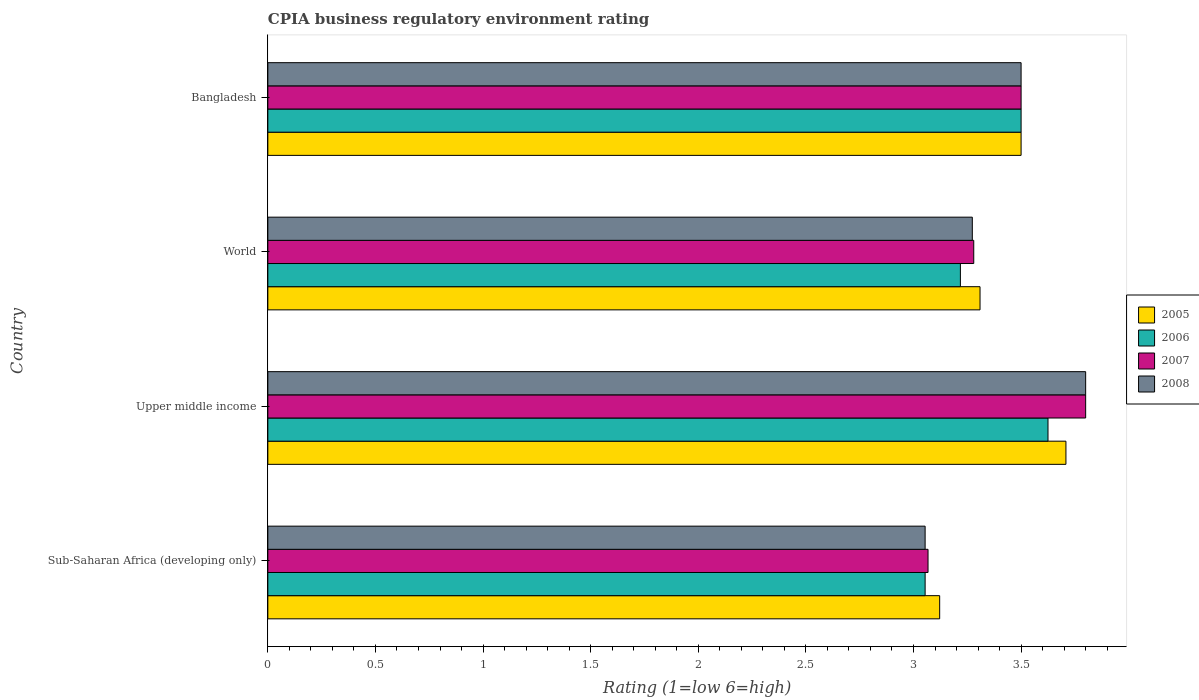How many different coloured bars are there?
Your answer should be very brief. 4. How many groups of bars are there?
Ensure brevity in your answer.  4. Are the number of bars per tick equal to the number of legend labels?
Offer a very short reply. Yes. Are the number of bars on each tick of the Y-axis equal?
Your answer should be very brief. Yes. How many bars are there on the 3rd tick from the top?
Provide a succinct answer. 4. What is the label of the 4th group of bars from the top?
Give a very brief answer. Sub-Saharan Africa (developing only). In how many cases, is the number of bars for a given country not equal to the number of legend labels?
Give a very brief answer. 0. What is the CPIA rating in 2007 in World?
Your response must be concise. 3.28. Across all countries, what is the maximum CPIA rating in 2005?
Offer a very short reply. 3.71. Across all countries, what is the minimum CPIA rating in 2005?
Provide a succinct answer. 3.12. In which country was the CPIA rating in 2008 maximum?
Your answer should be very brief. Upper middle income. In which country was the CPIA rating in 2007 minimum?
Offer a terse response. Sub-Saharan Africa (developing only). What is the total CPIA rating in 2007 in the graph?
Offer a very short reply. 13.65. What is the difference between the CPIA rating in 2008 in Bangladesh and that in Upper middle income?
Your answer should be very brief. -0.3. What is the difference between the CPIA rating in 2008 in Bangladesh and the CPIA rating in 2006 in Sub-Saharan Africa (developing only)?
Provide a succinct answer. 0.45. What is the average CPIA rating in 2006 per country?
Give a very brief answer. 3.35. What is the difference between the CPIA rating in 2005 and CPIA rating in 2006 in Sub-Saharan Africa (developing only)?
Make the answer very short. 0.07. What is the ratio of the CPIA rating in 2008 in Sub-Saharan Africa (developing only) to that in World?
Make the answer very short. 0.93. Is the difference between the CPIA rating in 2005 in Bangladesh and Sub-Saharan Africa (developing only) greater than the difference between the CPIA rating in 2006 in Bangladesh and Sub-Saharan Africa (developing only)?
Offer a terse response. No. What is the difference between the highest and the second highest CPIA rating in 2007?
Offer a very short reply. 0.3. What is the difference between the highest and the lowest CPIA rating in 2008?
Provide a succinct answer. 0.75. Is the sum of the CPIA rating in 2006 in Bangladesh and Upper middle income greater than the maximum CPIA rating in 2008 across all countries?
Ensure brevity in your answer.  Yes. Is it the case that in every country, the sum of the CPIA rating in 2005 and CPIA rating in 2007 is greater than the sum of CPIA rating in 2008 and CPIA rating in 2006?
Provide a succinct answer. No. What does the 2nd bar from the top in Sub-Saharan Africa (developing only) represents?
Your answer should be very brief. 2007. Is it the case that in every country, the sum of the CPIA rating in 2006 and CPIA rating in 2007 is greater than the CPIA rating in 2005?
Provide a short and direct response. Yes. What is the difference between two consecutive major ticks on the X-axis?
Your answer should be very brief. 0.5. Does the graph contain any zero values?
Offer a terse response. No. Does the graph contain grids?
Ensure brevity in your answer.  No. Where does the legend appear in the graph?
Your answer should be compact. Center right. How are the legend labels stacked?
Offer a terse response. Vertical. What is the title of the graph?
Ensure brevity in your answer.  CPIA business regulatory environment rating. Does "2015" appear as one of the legend labels in the graph?
Offer a very short reply. No. What is the label or title of the X-axis?
Offer a very short reply. Rating (1=low 6=high). What is the Rating (1=low 6=high) of 2005 in Sub-Saharan Africa (developing only)?
Make the answer very short. 3.12. What is the Rating (1=low 6=high) of 2006 in Sub-Saharan Africa (developing only)?
Your response must be concise. 3.05. What is the Rating (1=low 6=high) in 2007 in Sub-Saharan Africa (developing only)?
Make the answer very short. 3.07. What is the Rating (1=low 6=high) in 2008 in Sub-Saharan Africa (developing only)?
Offer a terse response. 3.05. What is the Rating (1=low 6=high) of 2005 in Upper middle income?
Your response must be concise. 3.71. What is the Rating (1=low 6=high) in 2006 in Upper middle income?
Offer a very short reply. 3.62. What is the Rating (1=low 6=high) in 2005 in World?
Your answer should be compact. 3.31. What is the Rating (1=low 6=high) of 2006 in World?
Offer a very short reply. 3.22. What is the Rating (1=low 6=high) of 2007 in World?
Offer a terse response. 3.28. What is the Rating (1=low 6=high) in 2008 in World?
Your answer should be very brief. 3.27. What is the Rating (1=low 6=high) of 2005 in Bangladesh?
Offer a very short reply. 3.5. What is the Rating (1=low 6=high) of 2008 in Bangladesh?
Provide a succinct answer. 3.5. Across all countries, what is the maximum Rating (1=low 6=high) in 2005?
Your answer should be compact. 3.71. Across all countries, what is the maximum Rating (1=low 6=high) in 2006?
Ensure brevity in your answer.  3.62. Across all countries, what is the minimum Rating (1=low 6=high) in 2005?
Make the answer very short. 3.12. Across all countries, what is the minimum Rating (1=low 6=high) in 2006?
Your response must be concise. 3.05. Across all countries, what is the minimum Rating (1=low 6=high) in 2007?
Provide a short and direct response. 3.07. Across all countries, what is the minimum Rating (1=low 6=high) of 2008?
Ensure brevity in your answer.  3.05. What is the total Rating (1=low 6=high) in 2005 in the graph?
Make the answer very short. 13.64. What is the total Rating (1=low 6=high) of 2006 in the graph?
Make the answer very short. 13.4. What is the total Rating (1=low 6=high) in 2007 in the graph?
Keep it short and to the point. 13.65. What is the total Rating (1=low 6=high) of 2008 in the graph?
Offer a very short reply. 13.63. What is the difference between the Rating (1=low 6=high) in 2005 in Sub-Saharan Africa (developing only) and that in Upper middle income?
Your response must be concise. -0.59. What is the difference between the Rating (1=low 6=high) in 2006 in Sub-Saharan Africa (developing only) and that in Upper middle income?
Ensure brevity in your answer.  -0.57. What is the difference between the Rating (1=low 6=high) of 2007 in Sub-Saharan Africa (developing only) and that in Upper middle income?
Ensure brevity in your answer.  -0.73. What is the difference between the Rating (1=low 6=high) in 2008 in Sub-Saharan Africa (developing only) and that in Upper middle income?
Provide a succinct answer. -0.75. What is the difference between the Rating (1=low 6=high) in 2005 in Sub-Saharan Africa (developing only) and that in World?
Provide a short and direct response. -0.19. What is the difference between the Rating (1=low 6=high) of 2006 in Sub-Saharan Africa (developing only) and that in World?
Provide a short and direct response. -0.16. What is the difference between the Rating (1=low 6=high) of 2007 in Sub-Saharan Africa (developing only) and that in World?
Your answer should be very brief. -0.21. What is the difference between the Rating (1=low 6=high) in 2008 in Sub-Saharan Africa (developing only) and that in World?
Ensure brevity in your answer.  -0.22. What is the difference between the Rating (1=low 6=high) in 2005 in Sub-Saharan Africa (developing only) and that in Bangladesh?
Provide a succinct answer. -0.38. What is the difference between the Rating (1=low 6=high) of 2006 in Sub-Saharan Africa (developing only) and that in Bangladesh?
Keep it short and to the point. -0.45. What is the difference between the Rating (1=low 6=high) of 2007 in Sub-Saharan Africa (developing only) and that in Bangladesh?
Provide a short and direct response. -0.43. What is the difference between the Rating (1=low 6=high) of 2008 in Sub-Saharan Africa (developing only) and that in Bangladesh?
Make the answer very short. -0.45. What is the difference between the Rating (1=low 6=high) in 2005 in Upper middle income and that in World?
Keep it short and to the point. 0.4. What is the difference between the Rating (1=low 6=high) in 2006 in Upper middle income and that in World?
Offer a very short reply. 0.41. What is the difference between the Rating (1=low 6=high) in 2007 in Upper middle income and that in World?
Provide a succinct answer. 0.52. What is the difference between the Rating (1=low 6=high) of 2008 in Upper middle income and that in World?
Give a very brief answer. 0.53. What is the difference between the Rating (1=low 6=high) in 2005 in Upper middle income and that in Bangladesh?
Your response must be concise. 0.21. What is the difference between the Rating (1=low 6=high) of 2006 in Upper middle income and that in Bangladesh?
Your answer should be compact. 0.12. What is the difference between the Rating (1=low 6=high) in 2005 in World and that in Bangladesh?
Offer a very short reply. -0.19. What is the difference between the Rating (1=low 6=high) of 2006 in World and that in Bangladesh?
Give a very brief answer. -0.28. What is the difference between the Rating (1=low 6=high) in 2007 in World and that in Bangladesh?
Provide a short and direct response. -0.22. What is the difference between the Rating (1=low 6=high) in 2008 in World and that in Bangladesh?
Offer a terse response. -0.23. What is the difference between the Rating (1=low 6=high) in 2005 in Sub-Saharan Africa (developing only) and the Rating (1=low 6=high) in 2006 in Upper middle income?
Ensure brevity in your answer.  -0.5. What is the difference between the Rating (1=low 6=high) of 2005 in Sub-Saharan Africa (developing only) and the Rating (1=low 6=high) of 2007 in Upper middle income?
Offer a very short reply. -0.68. What is the difference between the Rating (1=low 6=high) of 2005 in Sub-Saharan Africa (developing only) and the Rating (1=low 6=high) of 2008 in Upper middle income?
Provide a succinct answer. -0.68. What is the difference between the Rating (1=low 6=high) of 2006 in Sub-Saharan Africa (developing only) and the Rating (1=low 6=high) of 2007 in Upper middle income?
Provide a short and direct response. -0.75. What is the difference between the Rating (1=low 6=high) in 2006 in Sub-Saharan Africa (developing only) and the Rating (1=low 6=high) in 2008 in Upper middle income?
Your response must be concise. -0.75. What is the difference between the Rating (1=low 6=high) of 2007 in Sub-Saharan Africa (developing only) and the Rating (1=low 6=high) of 2008 in Upper middle income?
Offer a terse response. -0.73. What is the difference between the Rating (1=low 6=high) in 2005 in Sub-Saharan Africa (developing only) and the Rating (1=low 6=high) in 2006 in World?
Offer a very short reply. -0.1. What is the difference between the Rating (1=low 6=high) in 2005 in Sub-Saharan Africa (developing only) and the Rating (1=low 6=high) in 2007 in World?
Provide a succinct answer. -0.16. What is the difference between the Rating (1=low 6=high) in 2005 in Sub-Saharan Africa (developing only) and the Rating (1=low 6=high) in 2008 in World?
Your answer should be very brief. -0.15. What is the difference between the Rating (1=low 6=high) of 2006 in Sub-Saharan Africa (developing only) and the Rating (1=low 6=high) of 2007 in World?
Offer a terse response. -0.23. What is the difference between the Rating (1=low 6=high) of 2006 in Sub-Saharan Africa (developing only) and the Rating (1=low 6=high) of 2008 in World?
Offer a very short reply. -0.22. What is the difference between the Rating (1=low 6=high) of 2007 in Sub-Saharan Africa (developing only) and the Rating (1=low 6=high) of 2008 in World?
Your answer should be very brief. -0.21. What is the difference between the Rating (1=low 6=high) in 2005 in Sub-Saharan Africa (developing only) and the Rating (1=low 6=high) in 2006 in Bangladesh?
Provide a short and direct response. -0.38. What is the difference between the Rating (1=low 6=high) in 2005 in Sub-Saharan Africa (developing only) and the Rating (1=low 6=high) in 2007 in Bangladesh?
Provide a short and direct response. -0.38. What is the difference between the Rating (1=low 6=high) in 2005 in Sub-Saharan Africa (developing only) and the Rating (1=low 6=high) in 2008 in Bangladesh?
Your answer should be compact. -0.38. What is the difference between the Rating (1=low 6=high) of 2006 in Sub-Saharan Africa (developing only) and the Rating (1=low 6=high) of 2007 in Bangladesh?
Offer a terse response. -0.45. What is the difference between the Rating (1=low 6=high) in 2006 in Sub-Saharan Africa (developing only) and the Rating (1=low 6=high) in 2008 in Bangladesh?
Give a very brief answer. -0.45. What is the difference between the Rating (1=low 6=high) of 2007 in Sub-Saharan Africa (developing only) and the Rating (1=low 6=high) of 2008 in Bangladesh?
Provide a succinct answer. -0.43. What is the difference between the Rating (1=low 6=high) of 2005 in Upper middle income and the Rating (1=low 6=high) of 2006 in World?
Make the answer very short. 0.49. What is the difference between the Rating (1=low 6=high) in 2005 in Upper middle income and the Rating (1=low 6=high) in 2007 in World?
Give a very brief answer. 0.43. What is the difference between the Rating (1=low 6=high) in 2005 in Upper middle income and the Rating (1=low 6=high) in 2008 in World?
Your answer should be compact. 0.43. What is the difference between the Rating (1=low 6=high) in 2006 in Upper middle income and the Rating (1=low 6=high) in 2007 in World?
Keep it short and to the point. 0.34. What is the difference between the Rating (1=low 6=high) in 2006 in Upper middle income and the Rating (1=low 6=high) in 2008 in World?
Provide a short and direct response. 0.35. What is the difference between the Rating (1=low 6=high) of 2007 in Upper middle income and the Rating (1=low 6=high) of 2008 in World?
Give a very brief answer. 0.53. What is the difference between the Rating (1=low 6=high) in 2005 in Upper middle income and the Rating (1=low 6=high) in 2006 in Bangladesh?
Provide a succinct answer. 0.21. What is the difference between the Rating (1=low 6=high) in 2005 in Upper middle income and the Rating (1=low 6=high) in 2007 in Bangladesh?
Offer a very short reply. 0.21. What is the difference between the Rating (1=low 6=high) in 2005 in Upper middle income and the Rating (1=low 6=high) in 2008 in Bangladesh?
Your answer should be compact. 0.21. What is the difference between the Rating (1=low 6=high) in 2006 in Upper middle income and the Rating (1=low 6=high) in 2007 in Bangladesh?
Your answer should be very brief. 0.12. What is the difference between the Rating (1=low 6=high) in 2007 in Upper middle income and the Rating (1=low 6=high) in 2008 in Bangladesh?
Offer a terse response. 0.3. What is the difference between the Rating (1=low 6=high) in 2005 in World and the Rating (1=low 6=high) in 2006 in Bangladesh?
Make the answer very short. -0.19. What is the difference between the Rating (1=low 6=high) of 2005 in World and the Rating (1=low 6=high) of 2007 in Bangladesh?
Provide a succinct answer. -0.19. What is the difference between the Rating (1=low 6=high) of 2005 in World and the Rating (1=low 6=high) of 2008 in Bangladesh?
Provide a succinct answer. -0.19. What is the difference between the Rating (1=low 6=high) of 2006 in World and the Rating (1=low 6=high) of 2007 in Bangladesh?
Your answer should be very brief. -0.28. What is the difference between the Rating (1=low 6=high) in 2006 in World and the Rating (1=low 6=high) in 2008 in Bangladesh?
Ensure brevity in your answer.  -0.28. What is the difference between the Rating (1=low 6=high) of 2007 in World and the Rating (1=low 6=high) of 2008 in Bangladesh?
Offer a very short reply. -0.22. What is the average Rating (1=low 6=high) of 2005 per country?
Your answer should be very brief. 3.41. What is the average Rating (1=low 6=high) of 2006 per country?
Offer a terse response. 3.35. What is the average Rating (1=low 6=high) in 2007 per country?
Your answer should be very brief. 3.41. What is the average Rating (1=low 6=high) in 2008 per country?
Your answer should be compact. 3.41. What is the difference between the Rating (1=low 6=high) in 2005 and Rating (1=low 6=high) in 2006 in Sub-Saharan Africa (developing only)?
Offer a very short reply. 0.07. What is the difference between the Rating (1=low 6=high) of 2005 and Rating (1=low 6=high) of 2007 in Sub-Saharan Africa (developing only)?
Ensure brevity in your answer.  0.05. What is the difference between the Rating (1=low 6=high) in 2005 and Rating (1=low 6=high) in 2008 in Sub-Saharan Africa (developing only)?
Offer a terse response. 0.07. What is the difference between the Rating (1=low 6=high) in 2006 and Rating (1=low 6=high) in 2007 in Sub-Saharan Africa (developing only)?
Make the answer very short. -0.01. What is the difference between the Rating (1=low 6=high) in 2006 and Rating (1=low 6=high) in 2008 in Sub-Saharan Africa (developing only)?
Your response must be concise. 0. What is the difference between the Rating (1=low 6=high) of 2007 and Rating (1=low 6=high) of 2008 in Sub-Saharan Africa (developing only)?
Offer a terse response. 0.01. What is the difference between the Rating (1=low 6=high) of 2005 and Rating (1=low 6=high) of 2006 in Upper middle income?
Your answer should be compact. 0.08. What is the difference between the Rating (1=low 6=high) of 2005 and Rating (1=low 6=high) of 2007 in Upper middle income?
Give a very brief answer. -0.09. What is the difference between the Rating (1=low 6=high) of 2005 and Rating (1=low 6=high) of 2008 in Upper middle income?
Your answer should be compact. -0.09. What is the difference between the Rating (1=low 6=high) in 2006 and Rating (1=low 6=high) in 2007 in Upper middle income?
Ensure brevity in your answer.  -0.17. What is the difference between the Rating (1=low 6=high) of 2006 and Rating (1=low 6=high) of 2008 in Upper middle income?
Provide a succinct answer. -0.17. What is the difference between the Rating (1=low 6=high) of 2007 and Rating (1=low 6=high) of 2008 in Upper middle income?
Keep it short and to the point. 0. What is the difference between the Rating (1=low 6=high) of 2005 and Rating (1=low 6=high) of 2006 in World?
Provide a succinct answer. 0.09. What is the difference between the Rating (1=low 6=high) in 2005 and Rating (1=low 6=high) in 2007 in World?
Offer a terse response. 0.03. What is the difference between the Rating (1=low 6=high) of 2005 and Rating (1=low 6=high) of 2008 in World?
Offer a very short reply. 0.04. What is the difference between the Rating (1=low 6=high) of 2006 and Rating (1=low 6=high) of 2007 in World?
Your answer should be very brief. -0.06. What is the difference between the Rating (1=low 6=high) in 2006 and Rating (1=low 6=high) in 2008 in World?
Ensure brevity in your answer.  -0.06. What is the difference between the Rating (1=low 6=high) of 2007 and Rating (1=low 6=high) of 2008 in World?
Offer a terse response. 0.01. What is the difference between the Rating (1=low 6=high) of 2005 and Rating (1=low 6=high) of 2006 in Bangladesh?
Offer a terse response. 0. What is the difference between the Rating (1=low 6=high) of 2005 and Rating (1=low 6=high) of 2008 in Bangladesh?
Provide a succinct answer. 0. What is the difference between the Rating (1=low 6=high) in 2006 and Rating (1=low 6=high) in 2007 in Bangladesh?
Give a very brief answer. 0. What is the difference between the Rating (1=low 6=high) in 2006 and Rating (1=low 6=high) in 2008 in Bangladesh?
Your response must be concise. 0. What is the ratio of the Rating (1=low 6=high) of 2005 in Sub-Saharan Africa (developing only) to that in Upper middle income?
Provide a succinct answer. 0.84. What is the ratio of the Rating (1=low 6=high) of 2006 in Sub-Saharan Africa (developing only) to that in Upper middle income?
Make the answer very short. 0.84. What is the ratio of the Rating (1=low 6=high) in 2007 in Sub-Saharan Africa (developing only) to that in Upper middle income?
Your answer should be compact. 0.81. What is the ratio of the Rating (1=low 6=high) of 2008 in Sub-Saharan Africa (developing only) to that in Upper middle income?
Your response must be concise. 0.8. What is the ratio of the Rating (1=low 6=high) of 2005 in Sub-Saharan Africa (developing only) to that in World?
Ensure brevity in your answer.  0.94. What is the ratio of the Rating (1=low 6=high) in 2006 in Sub-Saharan Africa (developing only) to that in World?
Provide a short and direct response. 0.95. What is the ratio of the Rating (1=low 6=high) of 2007 in Sub-Saharan Africa (developing only) to that in World?
Ensure brevity in your answer.  0.94. What is the ratio of the Rating (1=low 6=high) in 2008 in Sub-Saharan Africa (developing only) to that in World?
Provide a succinct answer. 0.93. What is the ratio of the Rating (1=low 6=high) of 2005 in Sub-Saharan Africa (developing only) to that in Bangladesh?
Offer a very short reply. 0.89. What is the ratio of the Rating (1=low 6=high) in 2006 in Sub-Saharan Africa (developing only) to that in Bangladesh?
Keep it short and to the point. 0.87. What is the ratio of the Rating (1=low 6=high) of 2007 in Sub-Saharan Africa (developing only) to that in Bangladesh?
Give a very brief answer. 0.88. What is the ratio of the Rating (1=low 6=high) in 2008 in Sub-Saharan Africa (developing only) to that in Bangladesh?
Your response must be concise. 0.87. What is the ratio of the Rating (1=low 6=high) in 2005 in Upper middle income to that in World?
Offer a terse response. 1.12. What is the ratio of the Rating (1=low 6=high) of 2006 in Upper middle income to that in World?
Your response must be concise. 1.13. What is the ratio of the Rating (1=low 6=high) of 2007 in Upper middle income to that in World?
Ensure brevity in your answer.  1.16. What is the ratio of the Rating (1=low 6=high) of 2008 in Upper middle income to that in World?
Your response must be concise. 1.16. What is the ratio of the Rating (1=low 6=high) in 2005 in Upper middle income to that in Bangladesh?
Your answer should be compact. 1.06. What is the ratio of the Rating (1=low 6=high) in 2006 in Upper middle income to that in Bangladesh?
Provide a short and direct response. 1.04. What is the ratio of the Rating (1=low 6=high) in 2007 in Upper middle income to that in Bangladesh?
Offer a very short reply. 1.09. What is the ratio of the Rating (1=low 6=high) in 2008 in Upper middle income to that in Bangladesh?
Your answer should be very brief. 1.09. What is the ratio of the Rating (1=low 6=high) in 2005 in World to that in Bangladesh?
Your answer should be compact. 0.95. What is the ratio of the Rating (1=low 6=high) in 2006 in World to that in Bangladesh?
Offer a terse response. 0.92. What is the ratio of the Rating (1=low 6=high) of 2007 in World to that in Bangladesh?
Your response must be concise. 0.94. What is the ratio of the Rating (1=low 6=high) in 2008 in World to that in Bangladesh?
Your answer should be compact. 0.94. What is the difference between the highest and the second highest Rating (1=low 6=high) in 2005?
Your answer should be compact. 0.21. What is the difference between the highest and the second highest Rating (1=low 6=high) in 2006?
Ensure brevity in your answer.  0.12. What is the difference between the highest and the lowest Rating (1=low 6=high) of 2005?
Offer a terse response. 0.59. What is the difference between the highest and the lowest Rating (1=low 6=high) of 2006?
Make the answer very short. 0.57. What is the difference between the highest and the lowest Rating (1=low 6=high) in 2007?
Your response must be concise. 0.73. What is the difference between the highest and the lowest Rating (1=low 6=high) of 2008?
Provide a succinct answer. 0.75. 